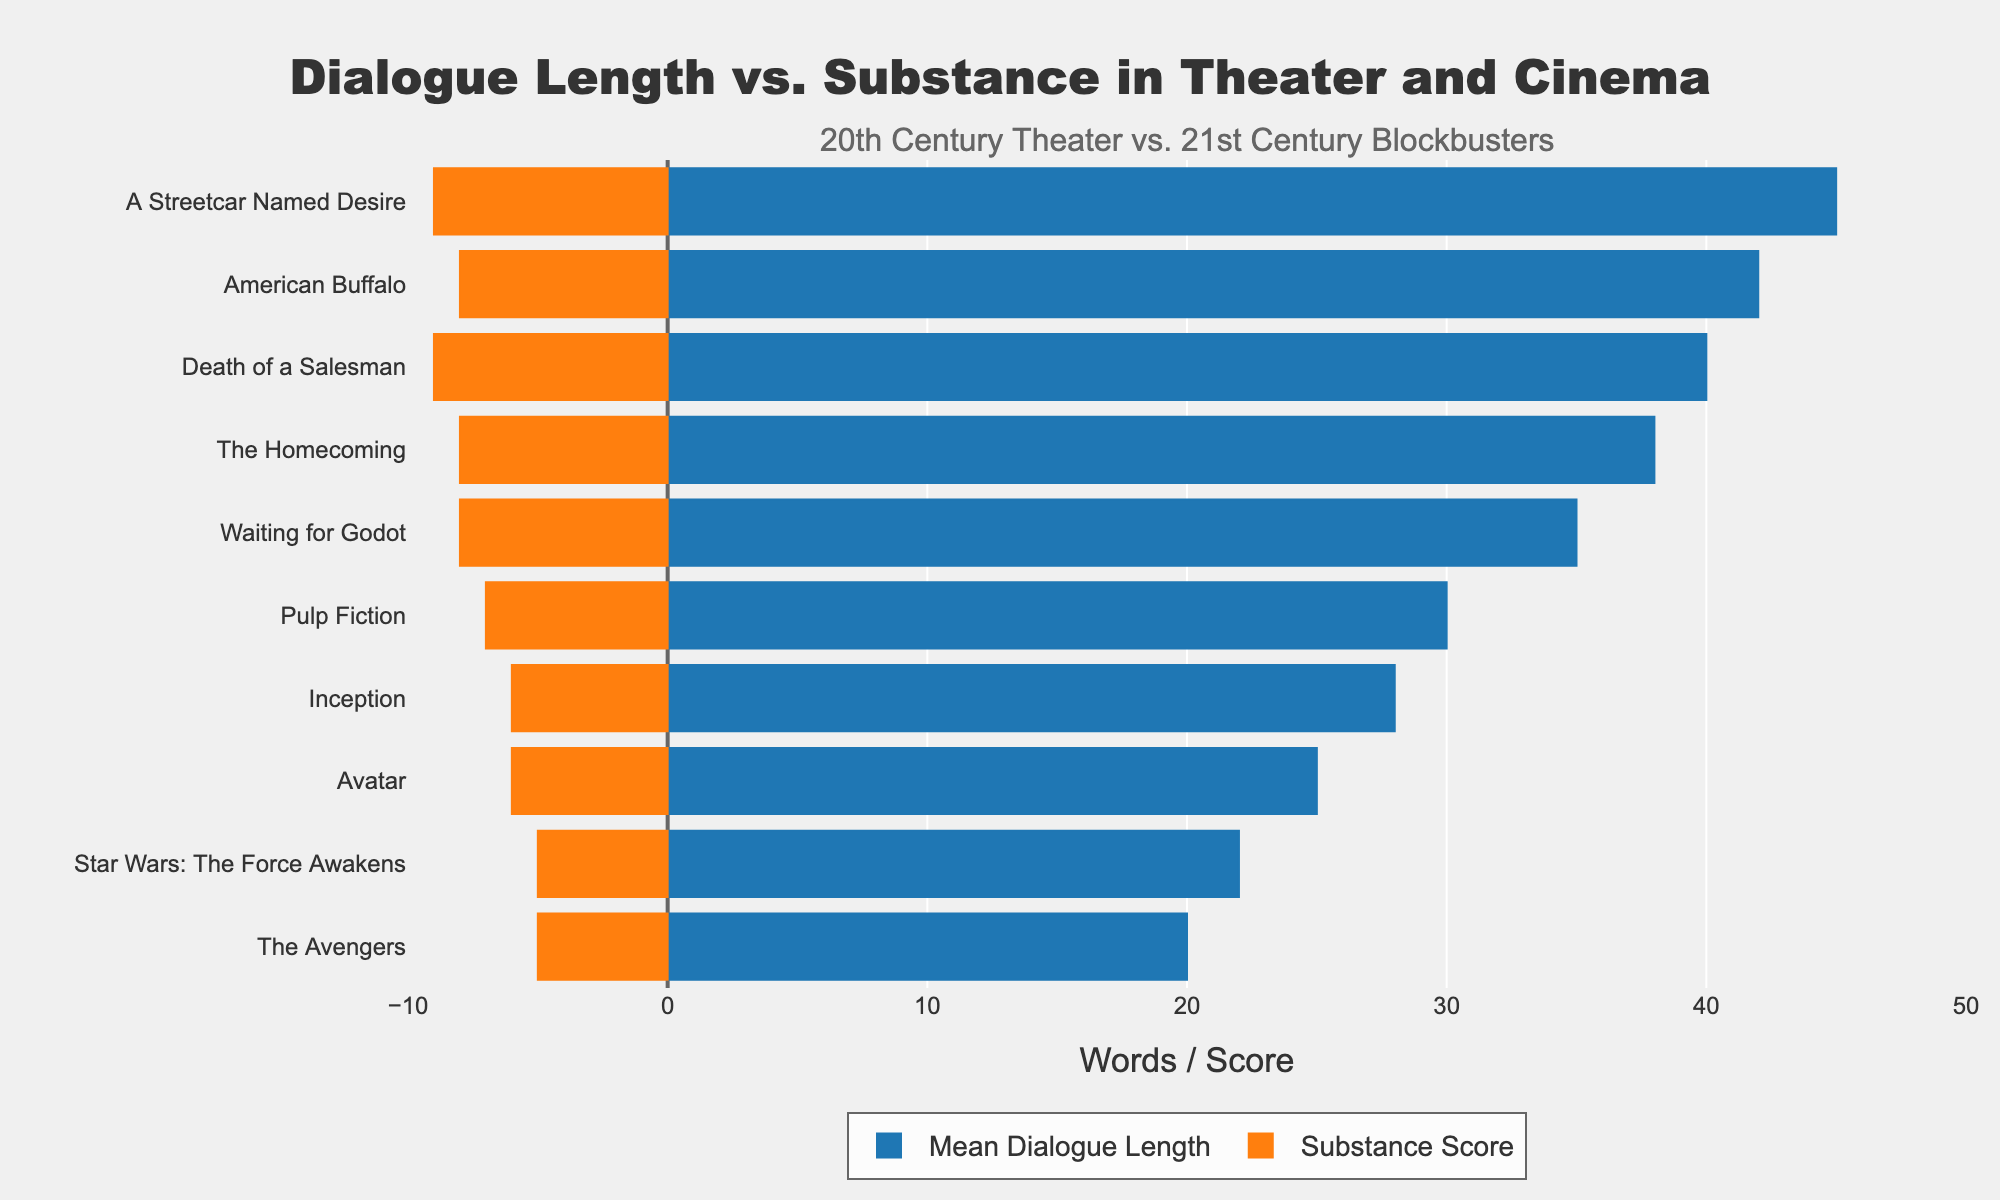What's the difference in mean dialogue length between 'Death of a Salesman' and 'The Avengers'? The mean dialogue length for 'Death of a Salesman' is 40 words, and for 'The Avengers' is 20 words. The difference is calculated by subtracting 20 from 40.
Answer: 20 words Which work has the highest substance score, and what's the value? The highest substance score is found by checking the maximum value in the substance score list. 'Death of a Salesman' and 'A Streetcar Named Desire' both have a substance score of 9, which is the highest.
Answer: 'Death of a Salesman' and 'A Streetcar Named Desire', 9 Are there any works with a mean dialogue length shorter than their substance score? If so, name one. By comparing each work's mean dialogue length and substance score, no work has a mean dialogue length that is shorter than its substance score. Thus, there are no such works.
Answer: No How does the mean dialogue length of 'Inception' compare to 'American Buffalo'? The mean dialogue length for 'Inception' is 28 words, and for 'American Buffalo' is 42 words. 28 is less than 42, indicating that 'Inception' has shorter dialogue on average compared to 'American Buffalo'.
Answer: 'Inception' is shorter Calculate the total mean dialogue length for all 20th century theater works. Add the mean dialogue lengths of 'Death of a Salesman' (40), 'A Streetcar Named Desire' (45), 'Waiting for Godot' (35), 'The Homecoming' (38), and 'American Buffalo' (42). The total is 40 + 45 + 35 + 38 + 42.
Answer: 200 words Which work has the lowest substance score, and how does it compare to the highest substance score? The lowest substance score is 5, seen in 'Star Wars: The Force Awakens' and 'The Avengers'. Comparing this value to the highest score of 9 (seen in 'Death of a Salesman' and 'A Streetcar Named Desire'), the difference is 9 - 5.
Answer: 'Star Wars: The Force Awakens' and 'The Avengers', 4 What's the average substance score across all the works? Sum up all the substance scores (9 + 9 + 8 + 8 + 8 + 7 + 6 + 6 + 5 + 5) and divide by the number of works (10). The total is 71, and the average is 71 / 10.
Answer: 7.1 Compare the mean dialogue length and substance score in 'Waiting for Godot'. Which one is higher? The mean dialogue length for 'Waiting for Godot' is 35 words, and the substance score is 8. 35 is greater than 8, so the mean dialogue length is higher.
Answer: Mean dialogue length What are the visual differences in the bar lengths for 'Pulp Fiction' compared to 'Star Wars: The Force Awakens'? The bar for 'Pulp Fiction' is longer for mean dialogue length (30) compared to 'Star Wars: The Force Awakens' (22). However, in the negative direction (substance scores), 'Pulp Fiction' (-7) is also longer compared to 'Star Wars: The Force Awakens' (-5).
Answer: 'Pulp Fiction', longer in both What proportion of 21st century blockbusters have a mean dialogue length below 30 words? Count the number of 21st century blockbusters with mean dialogue length below 30. There are 'Inception' (28), 'Avatar' (25), 'Star Wars: The Force Awakens' (22), and 'The Avengers' (20). Out of 5 blockbusters, 4 are below 30 words. The proportion is 4 / 5.
Answer: 4/5 or 80% 